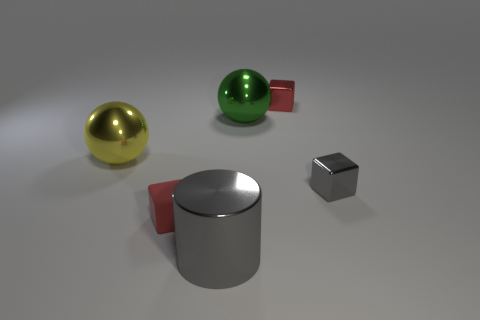There is a shiny block behind the metallic object that is left of the big gray cylinder that is to the left of the big green metal ball; what size is it?
Offer a very short reply. Small. There is a green ball that is the same size as the metal cylinder; what material is it?
Give a very brief answer. Metal. Is there a brown rubber sphere of the same size as the green metal object?
Make the answer very short. No. Do the big gray thing and the yellow object have the same shape?
Your response must be concise. No. Are there any red metal things in front of the small cube that is to the left of the red cube behind the large green metal sphere?
Your answer should be compact. No. How many other things are the same color as the small matte object?
Give a very brief answer. 1. There is a block left of the big green object; is it the same size as the red cube on the right side of the big shiny cylinder?
Offer a terse response. Yes. Are there an equal number of gray shiny cylinders that are to the right of the small gray object and large cylinders behind the large yellow object?
Offer a terse response. Yes. There is a green sphere; is it the same size as the red block that is in front of the tiny gray thing?
Ensure brevity in your answer.  No. What material is the red cube on the right side of the large green metallic object behind the large yellow object?
Ensure brevity in your answer.  Metal. 